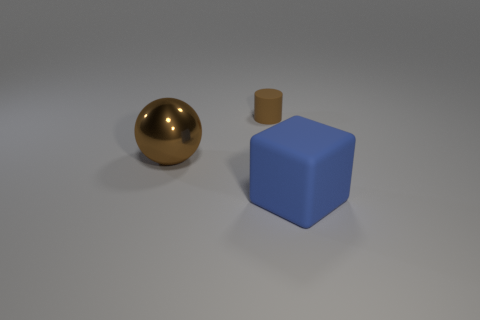There is a thing that is both in front of the cylinder and on the right side of the large shiny object; what shape is it?
Provide a short and direct response. Cube. There is a cylinder that is behind the metallic thing; is there a big brown thing behind it?
Keep it short and to the point. No. What number of other things are the same material as the large sphere?
Offer a terse response. 0. There is a large thing that is behind the big matte block; does it have the same shape as the matte object left of the blue matte cube?
Your answer should be very brief. No. Is the big cube made of the same material as the small object?
Keep it short and to the point. Yes. How big is the rubber object to the left of the matte thing on the right side of the matte object left of the big rubber object?
Provide a succinct answer. Small. What number of other things are there of the same color as the big matte block?
Give a very brief answer. 0. There is a thing that is the same size as the brown shiny ball; what is its shape?
Offer a terse response. Cube. What number of tiny objects are metal spheres or brown rubber objects?
Your answer should be very brief. 1. There is a large object that is left of the rubber object left of the block; are there any big brown balls behind it?
Your answer should be compact. No. 